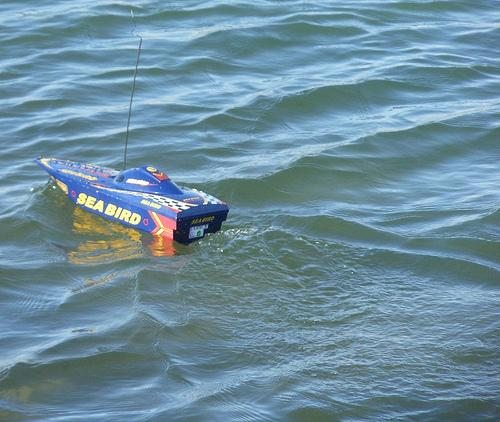What is unusual about the toy boat, and what's on top of it? The toy boat is a radio-controlled Formula One race boat with an antennae and a silver metal pole sticking out of it. Analyze the context of the image to describe what is happening. A colorful, radio-controlled toy boat named Sea Bird is floating and leaving a wake on a wavy body of water, creating ripples and small waves. What can you observe about the boat's reflection in the water? The boat's reflection can be seen on the water's surface. Can you identify the texture of the water's surface? There are ripples and small waves on the water's surface. What is the boat made of, and how is it controlled? The boat is made of plastic, and it is radio-controlled. What is the primary object in the image and its color? The primary object is a toy boat, which is blue in color. Briefly describe the water in the image. The water is wavy, colorless, and has small waves with some ripples on the surface. What sentiment does the image convey? The image conveys a playful and fun sentiment with a colorful toy boat in motion on the water. Are there any anomalies in the image regarding the boat or water? No, there are no apparent anomalies in the image regarding the boat or water. Can you provide details about the boat's name and design? The boat's name is Sea Bird, written in yellow, and it has red and yellow stripes along with two checkered flags painted over the engine room. The writing on the boat is in white cursive lettering, can you read the words clearly? No, it's not mentioned in the image. Observe the flock of birds flying across the skies above the water. There is no mention of birds flying, although the word "bird" is mentioned in reference to the boat name 'Sea Bird'. Is the boat green and covered in flowers? The boat in the image is described as blue and there is no mention of flowers on its surface. 